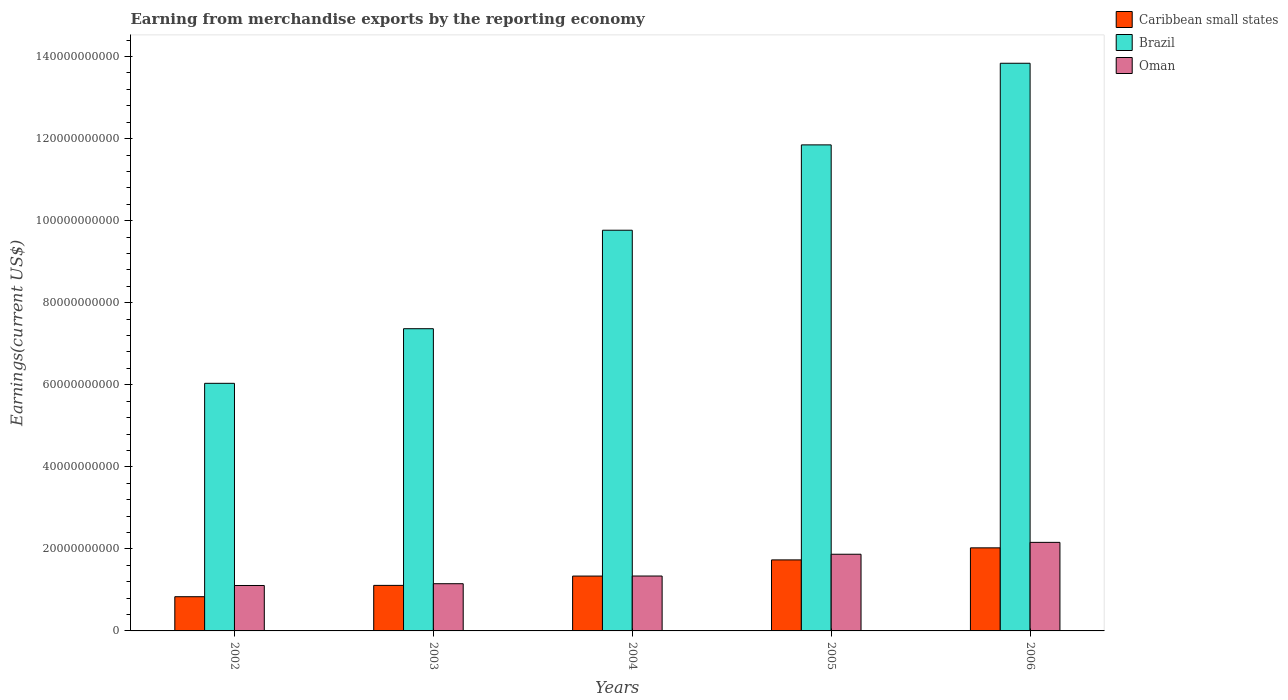Are the number of bars on each tick of the X-axis equal?
Provide a succinct answer. Yes. How many bars are there on the 4th tick from the left?
Keep it short and to the point. 3. How many bars are there on the 4th tick from the right?
Provide a short and direct response. 3. In how many cases, is the number of bars for a given year not equal to the number of legend labels?
Give a very brief answer. 0. What is the amount earned from merchandise exports in Brazil in 2005?
Provide a short and direct response. 1.18e+11. Across all years, what is the maximum amount earned from merchandise exports in Caribbean small states?
Your answer should be very brief. 2.02e+1. Across all years, what is the minimum amount earned from merchandise exports in Oman?
Provide a succinct answer. 1.11e+1. In which year was the amount earned from merchandise exports in Brazil minimum?
Make the answer very short. 2002. What is the total amount earned from merchandise exports in Caribbean small states in the graph?
Provide a short and direct response. 7.04e+1. What is the difference between the amount earned from merchandise exports in Brazil in 2002 and that in 2004?
Offer a very short reply. -3.73e+1. What is the difference between the amount earned from merchandise exports in Caribbean small states in 2003 and the amount earned from merchandise exports in Brazil in 2006?
Offer a very short reply. -1.27e+11. What is the average amount earned from merchandise exports in Brazil per year?
Offer a terse response. 9.77e+1. In the year 2006, what is the difference between the amount earned from merchandise exports in Caribbean small states and amount earned from merchandise exports in Brazil?
Ensure brevity in your answer.  -1.18e+11. What is the ratio of the amount earned from merchandise exports in Oman in 2005 to that in 2006?
Keep it short and to the point. 0.87. Is the difference between the amount earned from merchandise exports in Caribbean small states in 2002 and 2006 greater than the difference between the amount earned from merchandise exports in Brazil in 2002 and 2006?
Give a very brief answer. Yes. What is the difference between the highest and the second highest amount earned from merchandise exports in Caribbean small states?
Your answer should be very brief. 2.94e+09. What is the difference between the highest and the lowest amount earned from merchandise exports in Brazil?
Your response must be concise. 7.80e+1. In how many years, is the amount earned from merchandise exports in Caribbean small states greater than the average amount earned from merchandise exports in Caribbean small states taken over all years?
Your response must be concise. 2. Is the sum of the amount earned from merchandise exports in Brazil in 2003 and 2004 greater than the maximum amount earned from merchandise exports in Caribbean small states across all years?
Your answer should be very brief. Yes. What does the 3rd bar from the left in 2005 represents?
Your response must be concise. Oman. What does the 3rd bar from the right in 2005 represents?
Offer a terse response. Caribbean small states. Is it the case that in every year, the sum of the amount earned from merchandise exports in Brazil and amount earned from merchandise exports in Caribbean small states is greater than the amount earned from merchandise exports in Oman?
Your answer should be very brief. Yes. How many bars are there?
Your answer should be very brief. 15. Are all the bars in the graph horizontal?
Offer a very short reply. No. Are the values on the major ticks of Y-axis written in scientific E-notation?
Keep it short and to the point. No. Does the graph contain grids?
Offer a very short reply. No. How many legend labels are there?
Offer a terse response. 3. How are the legend labels stacked?
Give a very brief answer. Vertical. What is the title of the graph?
Offer a very short reply. Earning from merchandise exports by the reporting economy. What is the label or title of the X-axis?
Your response must be concise. Years. What is the label or title of the Y-axis?
Provide a succinct answer. Earnings(current US$). What is the Earnings(current US$) of Caribbean small states in 2002?
Keep it short and to the point. 8.34e+09. What is the Earnings(current US$) in Brazil in 2002?
Offer a terse response. 6.04e+1. What is the Earnings(current US$) in Oman in 2002?
Offer a very short reply. 1.11e+1. What is the Earnings(current US$) of Caribbean small states in 2003?
Provide a short and direct response. 1.11e+1. What is the Earnings(current US$) of Brazil in 2003?
Make the answer very short. 7.37e+1. What is the Earnings(current US$) in Oman in 2003?
Offer a terse response. 1.15e+1. What is the Earnings(current US$) of Caribbean small states in 2004?
Make the answer very short. 1.34e+1. What is the Earnings(current US$) of Brazil in 2004?
Ensure brevity in your answer.  9.77e+1. What is the Earnings(current US$) in Oman in 2004?
Your answer should be compact. 1.34e+1. What is the Earnings(current US$) in Caribbean small states in 2005?
Make the answer very short. 1.73e+1. What is the Earnings(current US$) of Brazil in 2005?
Make the answer very short. 1.18e+11. What is the Earnings(current US$) in Oman in 2005?
Give a very brief answer. 1.87e+1. What is the Earnings(current US$) of Caribbean small states in 2006?
Give a very brief answer. 2.02e+1. What is the Earnings(current US$) in Brazil in 2006?
Your answer should be compact. 1.38e+11. What is the Earnings(current US$) in Oman in 2006?
Give a very brief answer. 2.16e+1. Across all years, what is the maximum Earnings(current US$) in Caribbean small states?
Offer a terse response. 2.02e+1. Across all years, what is the maximum Earnings(current US$) of Brazil?
Offer a very short reply. 1.38e+11. Across all years, what is the maximum Earnings(current US$) in Oman?
Your answer should be very brief. 2.16e+1. Across all years, what is the minimum Earnings(current US$) of Caribbean small states?
Ensure brevity in your answer.  8.34e+09. Across all years, what is the minimum Earnings(current US$) in Brazil?
Give a very brief answer. 6.04e+1. Across all years, what is the minimum Earnings(current US$) of Oman?
Ensure brevity in your answer.  1.11e+1. What is the total Earnings(current US$) of Caribbean small states in the graph?
Make the answer very short. 7.04e+1. What is the total Earnings(current US$) in Brazil in the graph?
Offer a very short reply. 4.89e+11. What is the total Earnings(current US$) in Oman in the graph?
Offer a terse response. 7.62e+1. What is the difference between the Earnings(current US$) of Caribbean small states in 2002 and that in 2003?
Your answer should be very brief. -2.76e+09. What is the difference between the Earnings(current US$) in Brazil in 2002 and that in 2003?
Provide a short and direct response. -1.33e+1. What is the difference between the Earnings(current US$) in Oman in 2002 and that in 2003?
Offer a terse response. -4.37e+08. What is the difference between the Earnings(current US$) in Caribbean small states in 2002 and that in 2004?
Your answer should be compact. -5.03e+09. What is the difference between the Earnings(current US$) of Brazil in 2002 and that in 2004?
Provide a short and direct response. -3.73e+1. What is the difference between the Earnings(current US$) of Oman in 2002 and that in 2004?
Provide a short and direct response. -2.31e+09. What is the difference between the Earnings(current US$) in Caribbean small states in 2002 and that in 2005?
Provide a succinct answer. -8.97e+09. What is the difference between the Earnings(current US$) of Brazil in 2002 and that in 2005?
Give a very brief answer. -5.81e+1. What is the difference between the Earnings(current US$) in Oman in 2002 and that in 2005?
Your answer should be very brief. -7.62e+09. What is the difference between the Earnings(current US$) of Caribbean small states in 2002 and that in 2006?
Offer a terse response. -1.19e+1. What is the difference between the Earnings(current US$) of Brazil in 2002 and that in 2006?
Offer a terse response. -7.80e+1. What is the difference between the Earnings(current US$) of Oman in 2002 and that in 2006?
Provide a short and direct response. -1.05e+1. What is the difference between the Earnings(current US$) in Caribbean small states in 2003 and that in 2004?
Your answer should be very brief. -2.27e+09. What is the difference between the Earnings(current US$) in Brazil in 2003 and that in 2004?
Your answer should be very brief. -2.40e+1. What is the difference between the Earnings(current US$) in Oman in 2003 and that in 2004?
Provide a short and direct response. -1.87e+09. What is the difference between the Earnings(current US$) of Caribbean small states in 2003 and that in 2005?
Provide a short and direct response. -6.21e+09. What is the difference between the Earnings(current US$) of Brazil in 2003 and that in 2005?
Keep it short and to the point. -4.48e+1. What is the difference between the Earnings(current US$) of Oman in 2003 and that in 2005?
Provide a succinct answer. -7.18e+09. What is the difference between the Earnings(current US$) of Caribbean small states in 2003 and that in 2006?
Your answer should be compact. -9.15e+09. What is the difference between the Earnings(current US$) in Brazil in 2003 and that in 2006?
Your response must be concise. -6.47e+1. What is the difference between the Earnings(current US$) of Oman in 2003 and that in 2006?
Provide a succinct answer. -1.01e+1. What is the difference between the Earnings(current US$) in Caribbean small states in 2004 and that in 2005?
Ensure brevity in your answer.  -3.94e+09. What is the difference between the Earnings(current US$) of Brazil in 2004 and that in 2005?
Keep it short and to the point. -2.08e+1. What is the difference between the Earnings(current US$) of Oman in 2004 and that in 2005?
Offer a very short reply. -5.31e+09. What is the difference between the Earnings(current US$) of Caribbean small states in 2004 and that in 2006?
Make the answer very short. -6.88e+09. What is the difference between the Earnings(current US$) in Brazil in 2004 and that in 2006?
Make the answer very short. -4.07e+1. What is the difference between the Earnings(current US$) of Oman in 2004 and that in 2006?
Keep it short and to the point. -8.20e+09. What is the difference between the Earnings(current US$) in Caribbean small states in 2005 and that in 2006?
Offer a very short reply. -2.94e+09. What is the difference between the Earnings(current US$) of Brazil in 2005 and that in 2006?
Make the answer very short. -1.99e+1. What is the difference between the Earnings(current US$) in Oman in 2005 and that in 2006?
Your answer should be very brief. -2.89e+09. What is the difference between the Earnings(current US$) of Caribbean small states in 2002 and the Earnings(current US$) of Brazil in 2003?
Ensure brevity in your answer.  -6.53e+1. What is the difference between the Earnings(current US$) in Caribbean small states in 2002 and the Earnings(current US$) in Oman in 2003?
Offer a terse response. -3.17e+09. What is the difference between the Earnings(current US$) in Brazil in 2002 and the Earnings(current US$) in Oman in 2003?
Give a very brief answer. 4.88e+1. What is the difference between the Earnings(current US$) of Caribbean small states in 2002 and the Earnings(current US$) of Brazil in 2004?
Provide a succinct answer. -8.93e+1. What is the difference between the Earnings(current US$) in Caribbean small states in 2002 and the Earnings(current US$) in Oman in 2004?
Your response must be concise. -5.04e+09. What is the difference between the Earnings(current US$) of Brazil in 2002 and the Earnings(current US$) of Oman in 2004?
Provide a succinct answer. 4.70e+1. What is the difference between the Earnings(current US$) of Caribbean small states in 2002 and the Earnings(current US$) of Brazil in 2005?
Offer a terse response. -1.10e+11. What is the difference between the Earnings(current US$) in Caribbean small states in 2002 and the Earnings(current US$) in Oman in 2005?
Your answer should be very brief. -1.04e+1. What is the difference between the Earnings(current US$) in Brazil in 2002 and the Earnings(current US$) in Oman in 2005?
Your answer should be very brief. 4.17e+1. What is the difference between the Earnings(current US$) in Caribbean small states in 2002 and the Earnings(current US$) in Brazil in 2006?
Provide a succinct answer. -1.30e+11. What is the difference between the Earnings(current US$) of Caribbean small states in 2002 and the Earnings(current US$) of Oman in 2006?
Provide a short and direct response. -1.32e+1. What is the difference between the Earnings(current US$) in Brazil in 2002 and the Earnings(current US$) in Oman in 2006?
Make the answer very short. 3.88e+1. What is the difference between the Earnings(current US$) in Caribbean small states in 2003 and the Earnings(current US$) in Brazil in 2004?
Your answer should be compact. -8.66e+1. What is the difference between the Earnings(current US$) of Caribbean small states in 2003 and the Earnings(current US$) of Oman in 2004?
Provide a succinct answer. -2.28e+09. What is the difference between the Earnings(current US$) in Brazil in 2003 and the Earnings(current US$) in Oman in 2004?
Give a very brief answer. 6.03e+1. What is the difference between the Earnings(current US$) of Caribbean small states in 2003 and the Earnings(current US$) of Brazil in 2005?
Ensure brevity in your answer.  -1.07e+11. What is the difference between the Earnings(current US$) in Caribbean small states in 2003 and the Earnings(current US$) in Oman in 2005?
Keep it short and to the point. -7.59e+09. What is the difference between the Earnings(current US$) of Brazil in 2003 and the Earnings(current US$) of Oman in 2005?
Give a very brief answer. 5.50e+1. What is the difference between the Earnings(current US$) in Caribbean small states in 2003 and the Earnings(current US$) in Brazil in 2006?
Your response must be concise. -1.27e+11. What is the difference between the Earnings(current US$) of Caribbean small states in 2003 and the Earnings(current US$) of Oman in 2006?
Ensure brevity in your answer.  -1.05e+1. What is the difference between the Earnings(current US$) in Brazil in 2003 and the Earnings(current US$) in Oman in 2006?
Ensure brevity in your answer.  5.21e+1. What is the difference between the Earnings(current US$) in Caribbean small states in 2004 and the Earnings(current US$) in Brazil in 2005?
Provide a short and direct response. -1.05e+11. What is the difference between the Earnings(current US$) of Caribbean small states in 2004 and the Earnings(current US$) of Oman in 2005?
Keep it short and to the point. -5.32e+09. What is the difference between the Earnings(current US$) in Brazil in 2004 and the Earnings(current US$) in Oman in 2005?
Provide a succinct answer. 7.90e+1. What is the difference between the Earnings(current US$) of Caribbean small states in 2004 and the Earnings(current US$) of Brazil in 2006?
Keep it short and to the point. -1.25e+11. What is the difference between the Earnings(current US$) in Caribbean small states in 2004 and the Earnings(current US$) in Oman in 2006?
Offer a terse response. -8.22e+09. What is the difference between the Earnings(current US$) of Brazil in 2004 and the Earnings(current US$) of Oman in 2006?
Ensure brevity in your answer.  7.61e+1. What is the difference between the Earnings(current US$) of Caribbean small states in 2005 and the Earnings(current US$) of Brazil in 2006?
Give a very brief answer. -1.21e+11. What is the difference between the Earnings(current US$) in Caribbean small states in 2005 and the Earnings(current US$) in Oman in 2006?
Your answer should be compact. -4.27e+09. What is the difference between the Earnings(current US$) in Brazil in 2005 and the Earnings(current US$) in Oman in 2006?
Make the answer very short. 9.69e+1. What is the average Earnings(current US$) of Caribbean small states per year?
Keep it short and to the point. 1.41e+1. What is the average Earnings(current US$) in Brazil per year?
Offer a terse response. 9.77e+1. What is the average Earnings(current US$) of Oman per year?
Make the answer very short. 1.52e+1. In the year 2002, what is the difference between the Earnings(current US$) in Caribbean small states and Earnings(current US$) in Brazil?
Keep it short and to the point. -5.20e+1. In the year 2002, what is the difference between the Earnings(current US$) in Caribbean small states and Earnings(current US$) in Oman?
Provide a succinct answer. -2.73e+09. In the year 2002, what is the difference between the Earnings(current US$) of Brazil and Earnings(current US$) of Oman?
Your response must be concise. 4.93e+1. In the year 2003, what is the difference between the Earnings(current US$) in Caribbean small states and Earnings(current US$) in Brazil?
Offer a terse response. -6.26e+1. In the year 2003, what is the difference between the Earnings(current US$) of Caribbean small states and Earnings(current US$) of Oman?
Your answer should be compact. -4.07e+08. In the year 2003, what is the difference between the Earnings(current US$) of Brazil and Earnings(current US$) of Oman?
Ensure brevity in your answer.  6.22e+1. In the year 2004, what is the difference between the Earnings(current US$) of Caribbean small states and Earnings(current US$) of Brazil?
Offer a very short reply. -8.43e+1. In the year 2004, what is the difference between the Earnings(current US$) of Caribbean small states and Earnings(current US$) of Oman?
Offer a terse response. -1.22e+07. In the year 2004, what is the difference between the Earnings(current US$) of Brazil and Earnings(current US$) of Oman?
Your answer should be compact. 8.43e+1. In the year 2005, what is the difference between the Earnings(current US$) of Caribbean small states and Earnings(current US$) of Brazil?
Offer a terse response. -1.01e+11. In the year 2005, what is the difference between the Earnings(current US$) of Caribbean small states and Earnings(current US$) of Oman?
Offer a terse response. -1.38e+09. In the year 2005, what is the difference between the Earnings(current US$) in Brazil and Earnings(current US$) in Oman?
Offer a terse response. 9.98e+1. In the year 2006, what is the difference between the Earnings(current US$) of Caribbean small states and Earnings(current US$) of Brazil?
Keep it short and to the point. -1.18e+11. In the year 2006, what is the difference between the Earnings(current US$) of Caribbean small states and Earnings(current US$) of Oman?
Give a very brief answer. -1.34e+09. In the year 2006, what is the difference between the Earnings(current US$) in Brazil and Earnings(current US$) in Oman?
Ensure brevity in your answer.  1.17e+11. What is the ratio of the Earnings(current US$) in Caribbean small states in 2002 to that in 2003?
Make the answer very short. 0.75. What is the ratio of the Earnings(current US$) of Brazil in 2002 to that in 2003?
Ensure brevity in your answer.  0.82. What is the ratio of the Earnings(current US$) of Oman in 2002 to that in 2003?
Ensure brevity in your answer.  0.96. What is the ratio of the Earnings(current US$) of Caribbean small states in 2002 to that in 2004?
Keep it short and to the point. 0.62. What is the ratio of the Earnings(current US$) in Brazil in 2002 to that in 2004?
Keep it short and to the point. 0.62. What is the ratio of the Earnings(current US$) of Oman in 2002 to that in 2004?
Your answer should be very brief. 0.83. What is the ratio of the Earnings(current US$) in Caribbean small states in 2002 to that in 2005?
Provide a succinct answer. 0.48. What is the ratio of the Earnings(current US$) of Brazil in 2002 to that in 2005?
Provide a succinct answer. 0.51. What is the ratio of the Earnings(current US$) in Oman in 2002 to that in 2005?
Your response must be concise. 0.59. What is the ratio of the Earnings(current US$) in Caribbean small states in 2002 to that in 2006?
Your response must be concise. 0.41. What is the ratio of the Earnings(current US$) of Brazil in 2002 to that in 2006?
Make the answer very short. 0.44. What is the ratio of the Earnings(current US$) of Oman in 2002 to that in 2006?
Offer a terse response. 0.51. What is the ratio of the Earnings(current US$) in Caribbean small states in 2003 to that in 2004?
Offer a very short reply. 0.83. What is the ratio of the Earnings(current US$) of Brazil in 2003 to that in 2004?
Offer a very short reply. 0.75. What is the ratio of the Earnings(current US$) in Oman in 2003 to that in 2004?
Offer a very short reply. 0.86. What is the ratio of the Earnings(current US$) of Caribbean small states in 2003 to that in 2005?
Ensure brevity in your answer.  0.64. What is the ratio of the Earnings(current US$) of Brazil in 2003 to that in 2005?
Offer a very short reply. 0.62. What is the ratio of the Earnings(current US$) of Oman in 2003 to that in 2005?
Provide a succinct answer. 0.62. What is the ratio of the Earnings(current US$) in Caribbean small states in 2003 to that in 2006?
Offer a terse response. 0.55. What is the ratio of the Earnings(current US$) in Brazil in 2003 to that in 2006?
Provide a short and direct response. 0.53. What is the ratio of the Earnings(current US$) of Oman in 2003 to that in 2006?
Your response must be concise. 0.53. What is the ratio of the Earnings(current US$) in Caribbean small states in 2004 to that in 2005?
Make the answer very short. 0.77. What is the ratio of the Earnings(current US$) of Brazil in 2004 to that in 2005?
Provide a succinct answer. 0.82. What is the ratio of the Earnings(current US$) in Oman in 2004 to that in 2005?
Make the answer very short. 0.72. What is the ratio of the Earnings(current US$) of Caribbean small states in 2004 to that in 2006?
Provide a succinct answer. 0.66. What is the ratio of the Earnings(current US$) of Brazil in 2004 to that in 2006?
Your response must be concise. 0.71. What is the ratio of the Earnings(current US$) in Oman in 2004 to that in 2006?
Give a very brief answer. 0.62. What is the ratio of the Earnings(current US$) in Caribbean small states in 2005 to that in 2006?
Ensure brevity in your answer.  0.85. What is the ratio of the Earnings(current US$) of Brazil in 2005 to that in 2006?
Your answer should be very brief. 0.86. What is the ratio of the Earnings(current US$) of Oman in 2005 to that in 2006?
Make the answer very short. 0.87. What is the difference between the highest and the second highest Earnings(current US$) in Caribbean small states?
Keep it short and to the point. 2.94e+09. What is the difference between the highest and the second highest Earnings(current US$) in Brazil?
Your response must be concise. 1.99e+1. What is the difference between the highest and the second highest Earnings(current US$) in Oman?
Give a very brief answer. 2.89e+09. What is the difference between the highest and the lowest Earnings(current US$) in Caribbean small states?
Your answer should be compact. 1.19e+1. What is the difference between the highest and the lowest Earnings(current US$) in Brazil?
Ensure brevity in your answer.  7.80e+1. What is the difference between the highest and the lowest Earnings(current US$) in Oman?
Ensure brevity in your answer.  1.05e+1. 